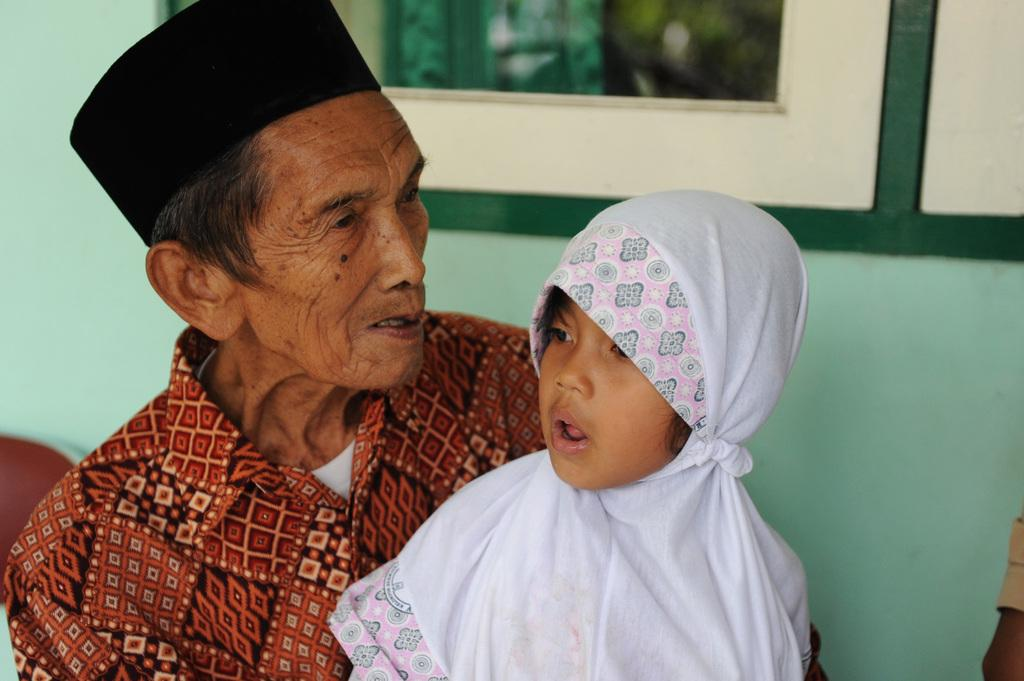What is the gender of the person in the image? There is a man in the image. What is the man wearing on his head? The man is wearing a black cap. What is the gender of the other person in the image? There is a girl in the image. What is the girl wearing around her neck? The girl is wearing a white color scarf. What can be seen in the background of the image? There is a green wall and a white color window in the background of the image. We start by identifying the two main subjects in the image, which are the man and the girl. We then describe their clothing and accessories to provide more detail about their appearance. Next, we focus on the background of the image, mentioning the green wall and the white color window. By doing so, we ensure that each question can be answered definitively with the information given. Absurd Question/Answer: Can you see any crates in the image? No, there are no crates present in the image. What type of fish can be seen swimming in the lake in the image? There is no lake or fish visible in the image. Can you see any crates in the image? No, there are no crates present in the image. What type of fish can be seen swimming in the lake in the image? There is no lake or fish visible in the image. 